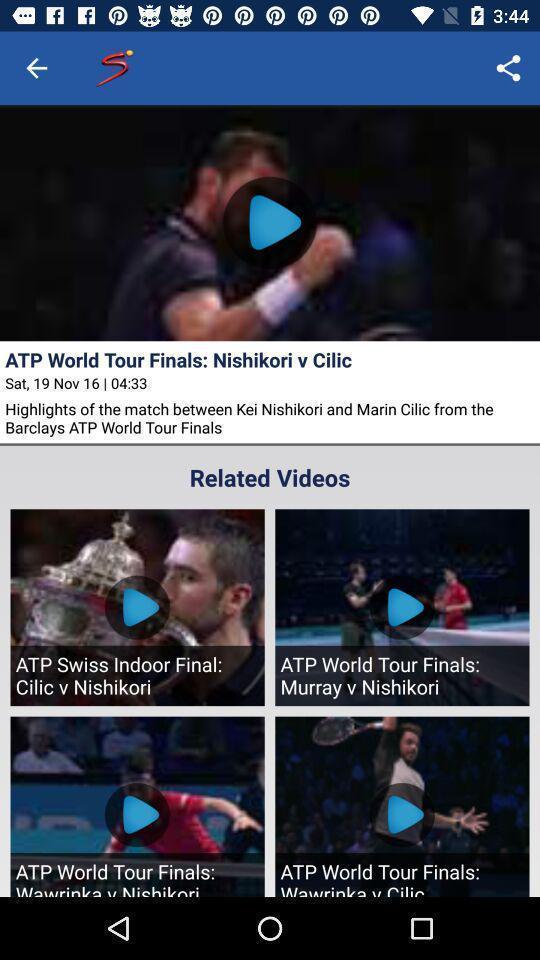Describe the key features of this screenshot. Page showing about different videos available. 